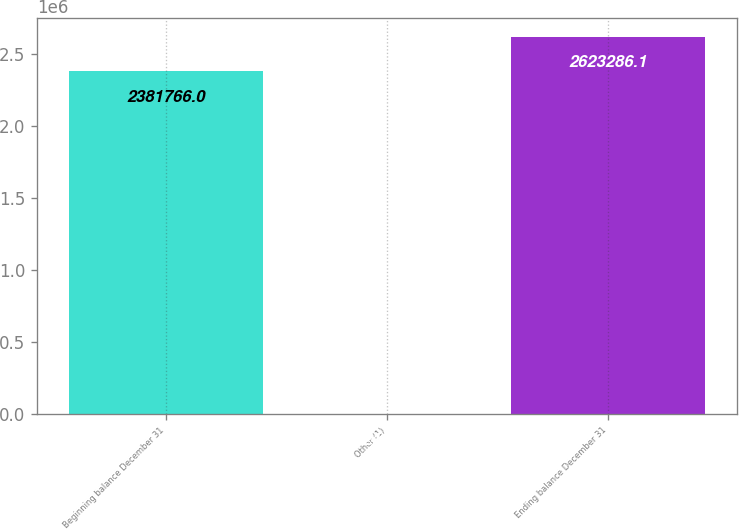Convert chart to OTSL. <chart><loc_0><loc_0><loc_500><loc_500><bar_chart><fcel>Beginning balance December 31<fcel>Other (1)<fcel>Ending balance December 31<nl><fcel>2.38177e+06<fcel>2447<fcel>2.62329e+06<nl></chart> 